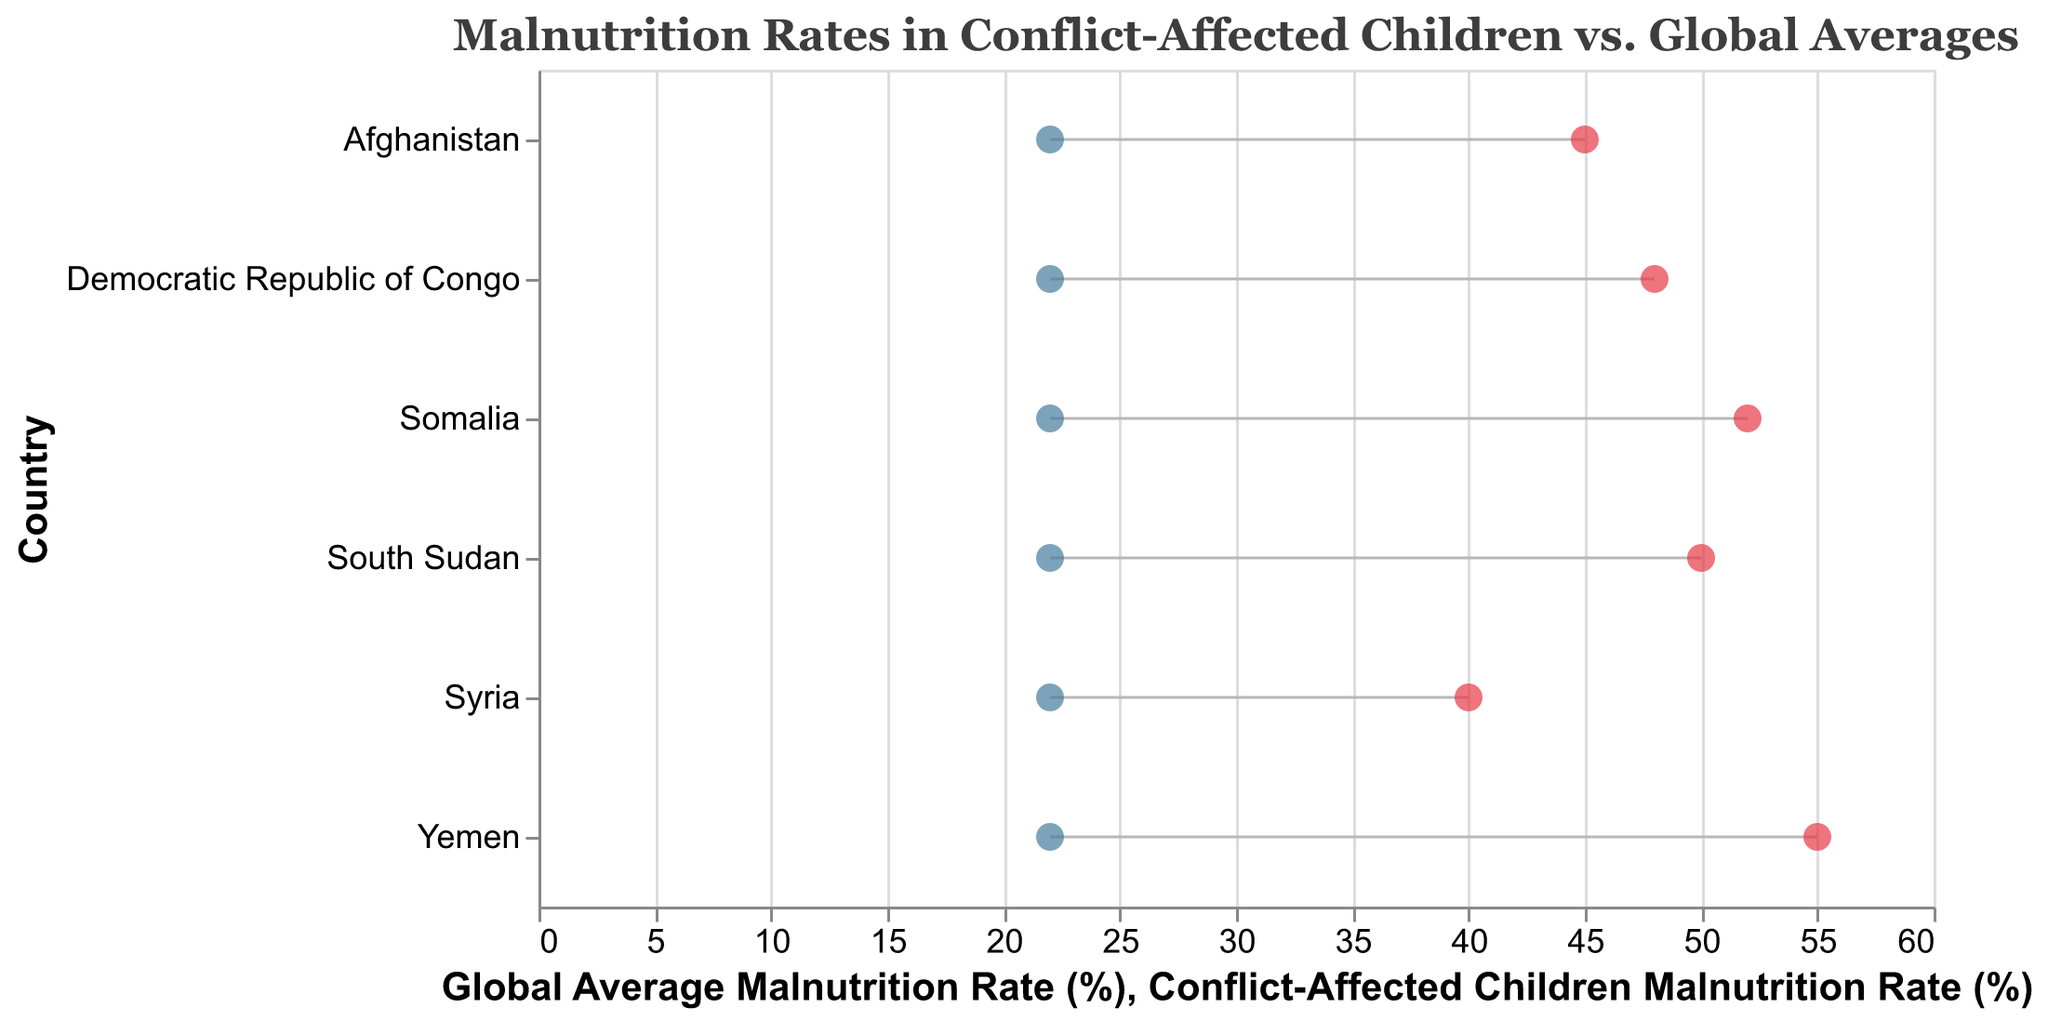Which country has the highest malnutrition rate among conflict-affected children? Among the countries listed, the dumbbell plot shows the highest malnutrition rate of 55% for Yemen.
Answer: Yemen How much higher is the malnutrition rate for conflict-affected children in Somalia compared to the global average? The difference in malnutrition rates can be calculated as 52% (Somalia) - 22% (global average).
Answer: 30% Which country has the smallest difference between conflict-affected children's malnutrition rate and the global average? The smallest difference can be observed by looking for the shortest dumbbell line, which is for Syria with a malnutrition rate difference of 40% (Syria) - 22% (global average).
Answer: Syria What is the average malnutrition rate for conflict-affected children across all listed countries? Sum the conflict-affected children malnutrition rates (55 + 40 + 50 + 45 + 52 + 48) and divide by the number of countries (6). The sum is 290, so the average is 290 / 6 ≈ 48.33%.
Answer: 48.33% How does the malnutrition rate of conflict-affected children in Afghanistan compare to that in South Sudan? The malnutrition rate for conflict-affected children in Afghanistan is 45%, while in South Sudan it is 50%. Therefore, South Sudan has a 5% higher malnutrition rate than Afghanistan.
Answer: South Sudan is 5% higher Which countries exceed the global average malnutrition rate by more than 25 percentage points? To find the countries exceeding the global average by more than 25 percentage points, look for those with a rate above 47% (22% + 25%). Yemen, South Sudan, Somalia, and Democratic Republic of Congo exceed this threshold.
Answer: Yemen, South Sudan, Somalia, Democratic Republic of Congo How much higher is the malnutrition rate for conflict-affected children in the Democratic Republic of Congo compared to Syria? The rate for the Democratic Republic of Congo is 48%, and for Syria, it is 40%. Thus, the difference is 48% - 40% = 8%.
Answer: 8% What is the median malnutrition rate for conflict-affected children in the listed countries? Ordering the rates (40%, 45%, 48%, 50%, 52%, 55%), the median is the average of the two middle values (48% + 50%) / 2 = 49%.
Answer: 49% Which country has the most considerable difference between conflict-affected children's malnutrition rate and the global average? The country with the most considerable difference will be the one with the longest dumbbell line, which is Yemen with a difference of 55% - 22%.
Answer: Yemen 